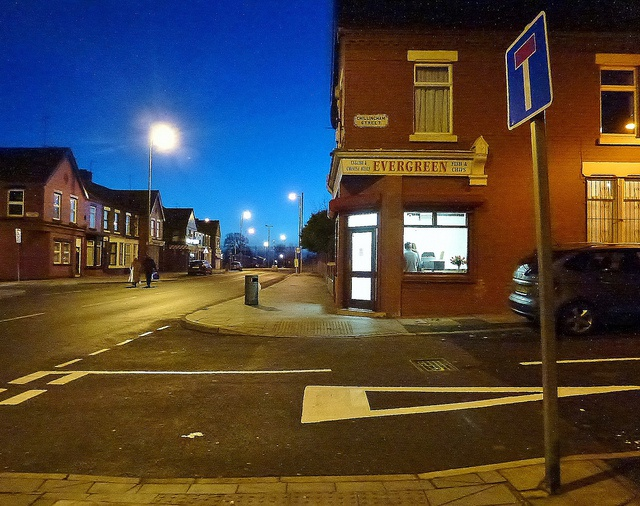Describe the objects in this image and their specific colors. I can see truck in navy, black, maroon, gray, and olive tones, car in navy, black, maroon, gray, and brown tones, people in navy, gray, teal, darkgray, and lightgray tones, car in navy, black, darkgray, gray, and maroon tones, and people in navy, maroon, black, and tan tones in this image. 